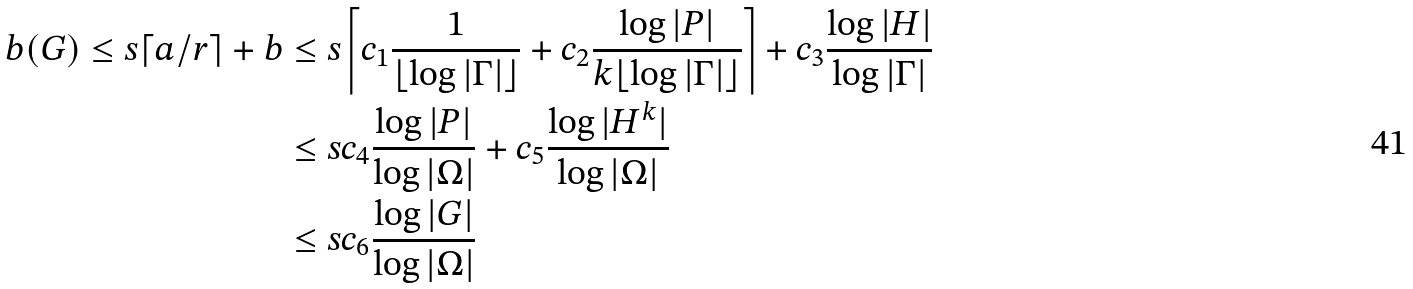<formula> <loc_0><loc_0><loc_500><loc_500>b ( G ) \leq s \lceil a / r \rceil + b & \leq s \left \lceil c _ { 1 } \frac { 1 } { \lfloor \log | \Gamma | \rfloor } + c _ { 2 } \frac { \log | P | } { k \lfloor \log | \Gamma | \rfloor } \right \rceil + c _ { 3 } \frac { \log | H | } { \log | \Gamma | } \\ & \leq s c _ { 4 } \frac { \log | P | } { \log | \Omega | } + c _ { 5 } \frac { \log | H ^ { k } | } { \log | \Omega | } \\ & \leq s c _ { 6 } \frac { \log | G | } { \log | \Omega | }</formula> 